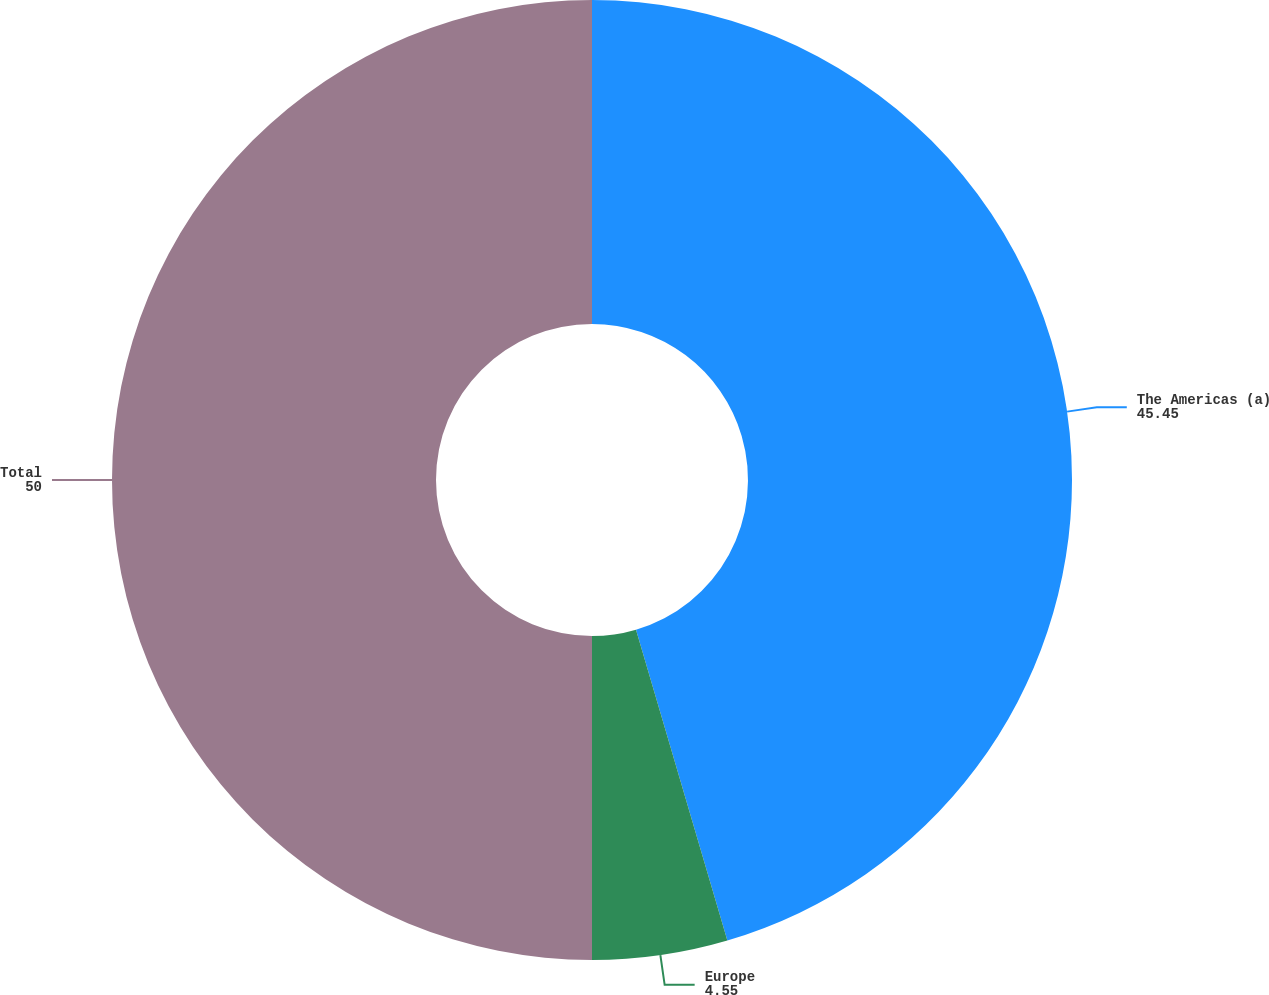<chart> <loc_0><loc_0><loc_500><loc_500><pie_chart><fcel>The Americas (a)<fcel>Europe<fcel>Total<nl><fcel>45.45%<fcel>4.55%<fcel>50.0%<nl></chart> 